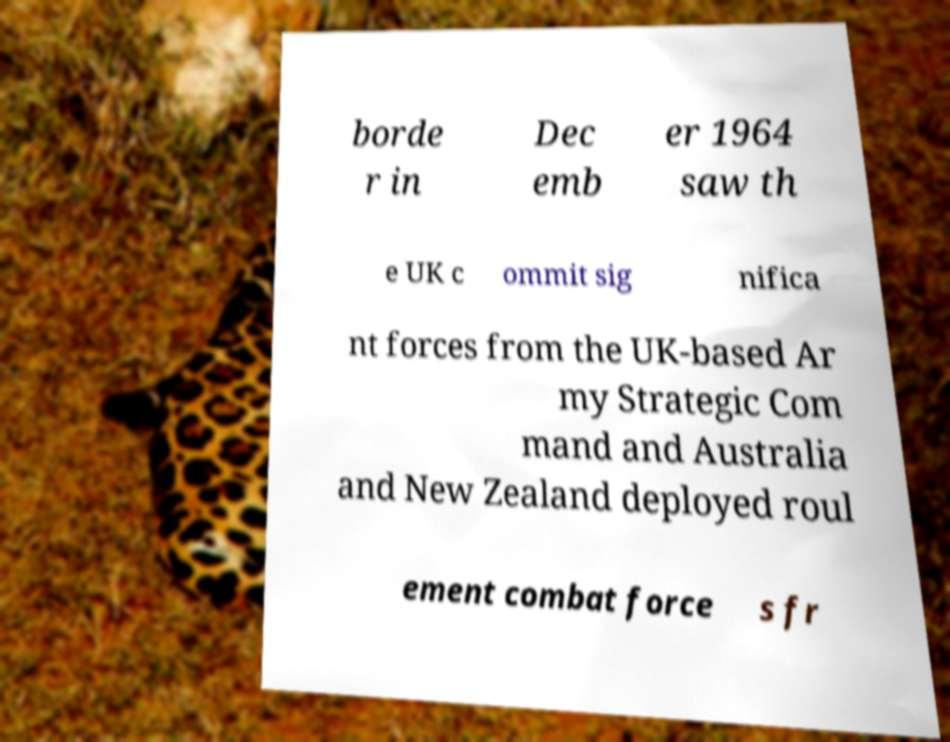Please read and relay the text visible in this image. What does it say? borde r in Dec emb er 1964 saw th e UK c ommit sig nifica nt forces from the UK-based Ar my Strategic Com mand and Australia and New Zealand deployed roul ement combat force s fr 